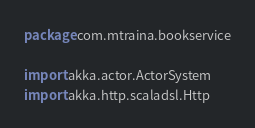Convert code to text. <code><loc_0><loc_0><loc_500><loc_500><_Scala_>package com.mtraina.bookservice

import akka.actor.ActorSystem
import akka.http.scaladsl.Http</code> 